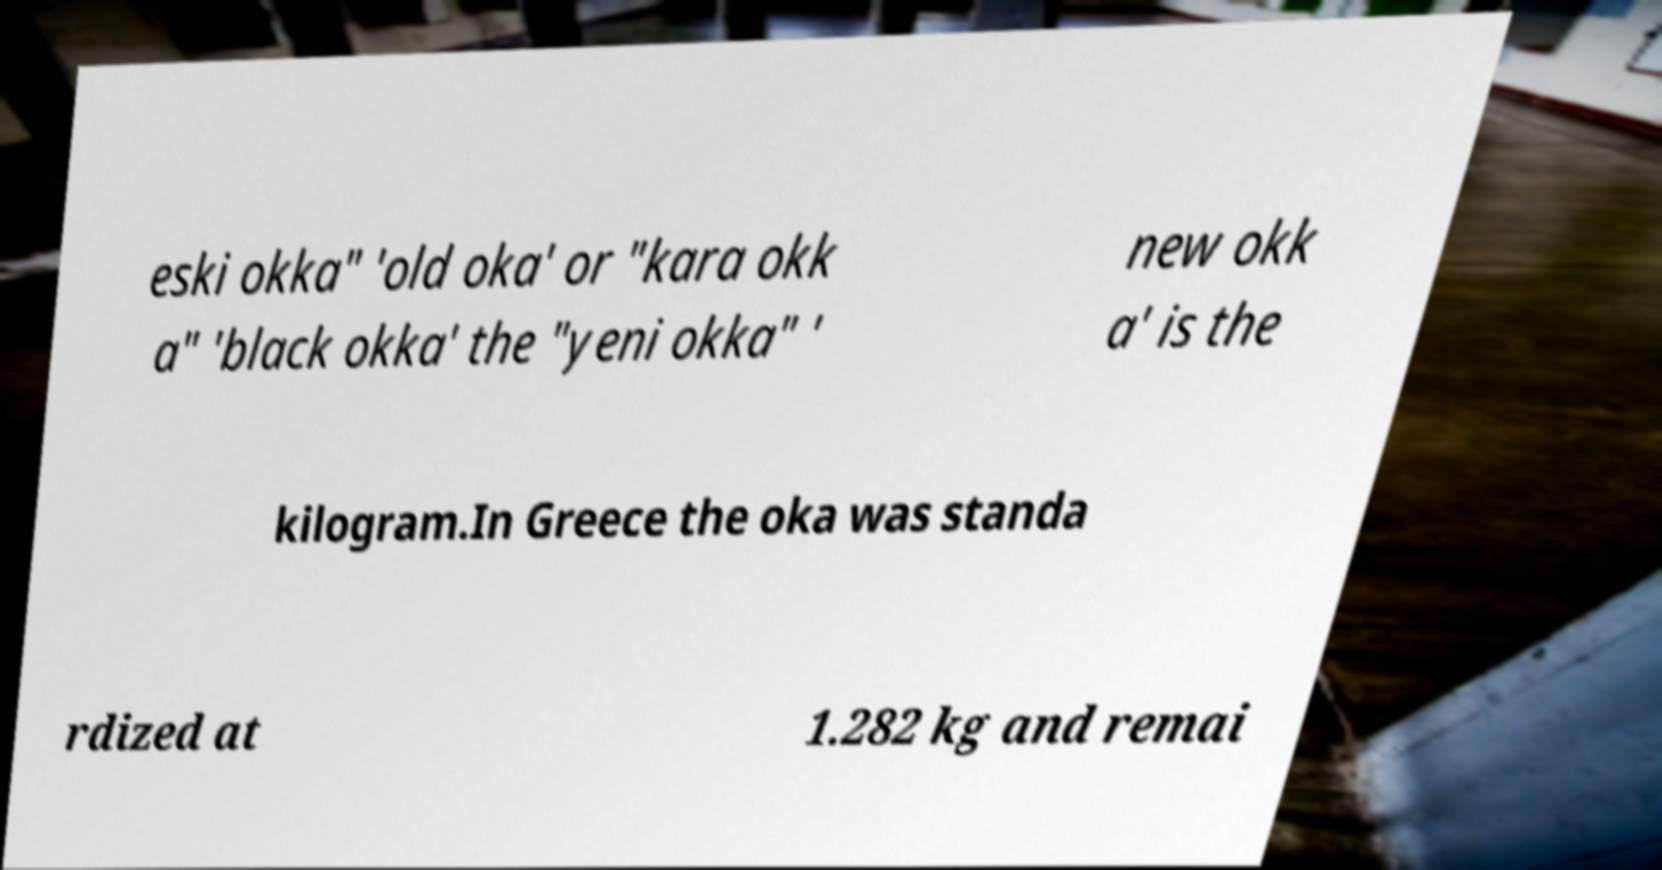Please read and relay the text visible in this image. What does it say? eski okka" 'old oka' or "kara okk a" 'black okka' the "yeni okka" ' new okk a' is the kilogram.In Greece the oka was standa rdized at 1.282 kg and remai 